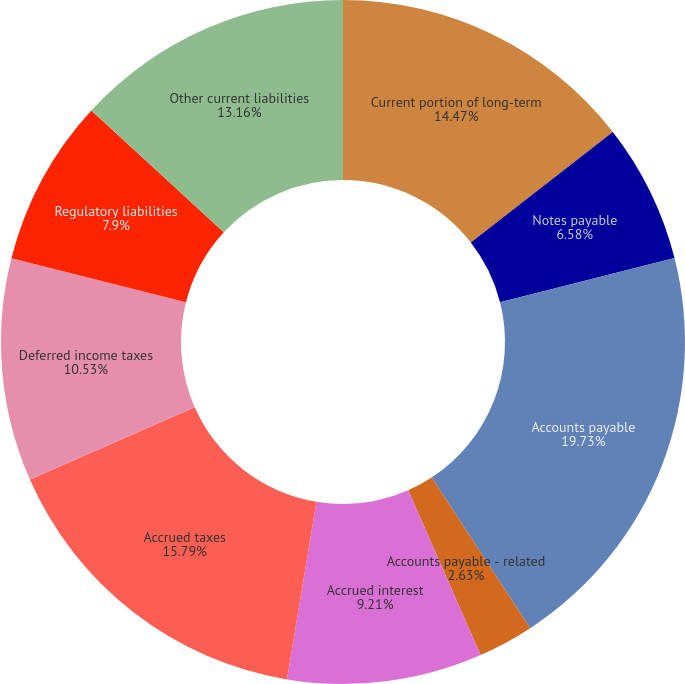Convert chart to OTSL. <chart><loc_0><loc_0><loc_500><loc_500><pie_chart><fcel>Current portion of long-term<fcel>Notes payable<fcel>Accounts payable<fcel>Accounts payable - related<fcel>Accrued rate refunds<fcel>Accrued interest<fcel>Accrued taxes<fcel>Deferred income taxes<fcel>Regulatory liabilities<fcel>Other current liabilities<nl><fcel>14.47%<fcel>6.58%<fcel>19.73%<fcel>2.63%<fcel>0.0%<fcel>9.21%<fcel>15.79%<fcel>10.53%<fcel>7.9%<fcel>13.16%<nl></chart> 